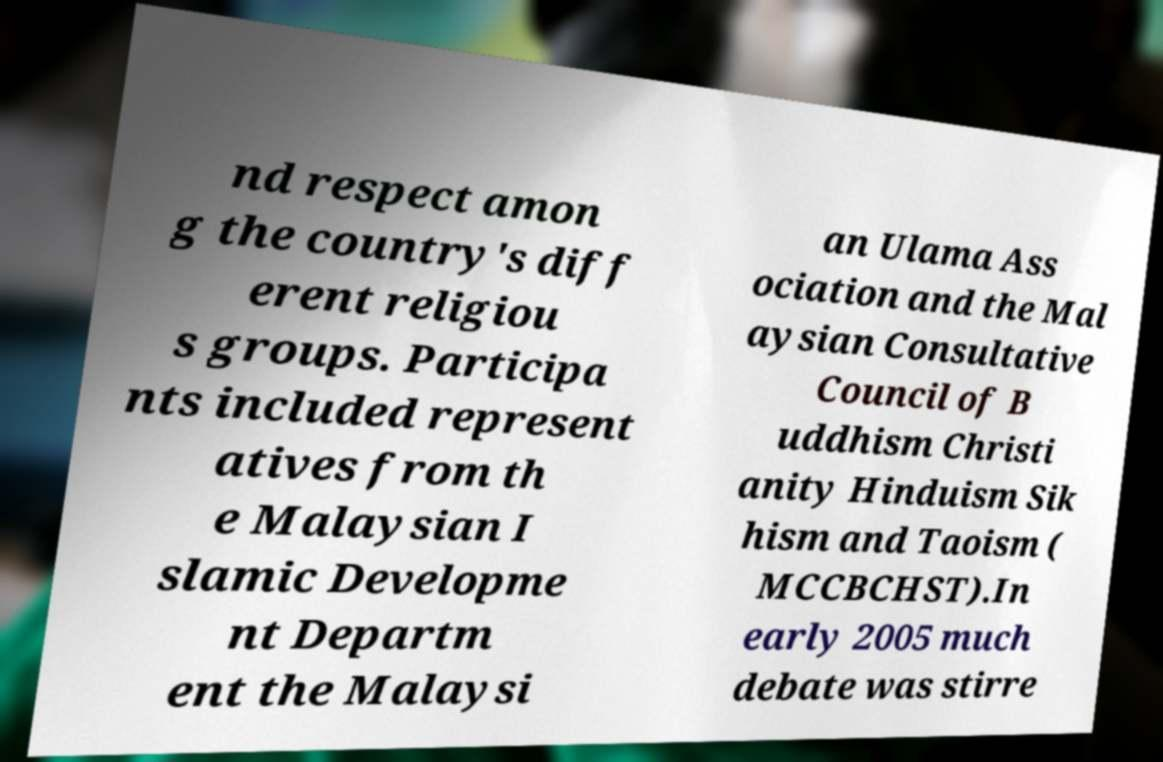Please read and relay the text visible in this image. What does it say? nd respect amon g the country's diff erent religiou s groups. Participa nts included represent atives from th e Malaysian I slamic Developme nt Departm ent the Malaysi an Ulama Ass ociation and the Mal aysian Consultative Council of B uddhism Christi anity Hinduism Sik hism and Taoism ( MCCBCHST).In early 2005 much debate was stirre 